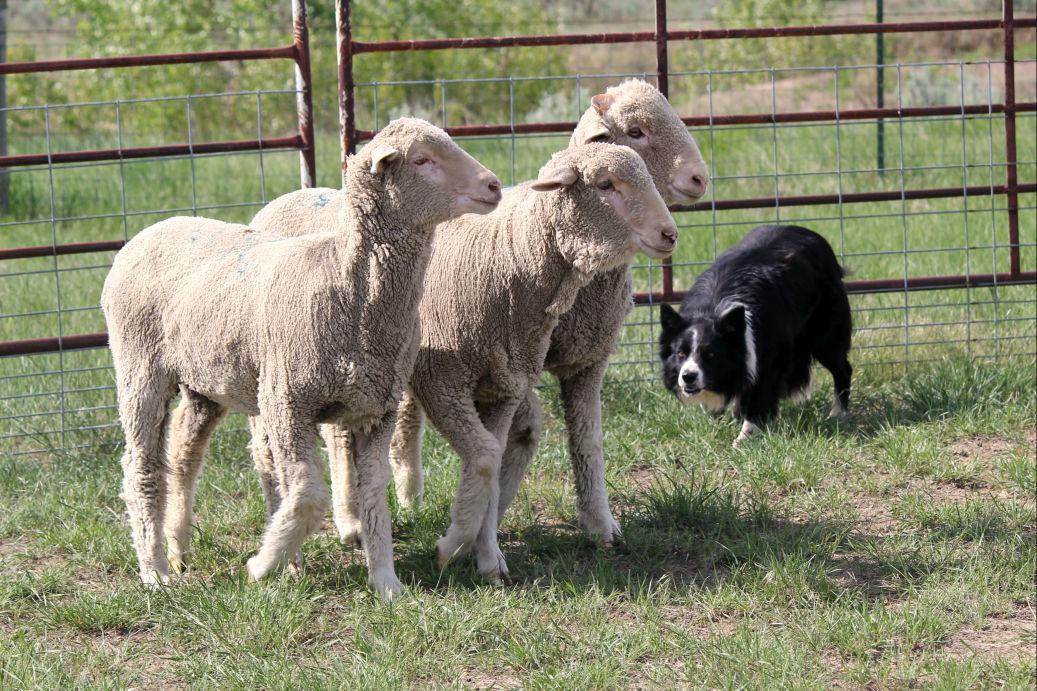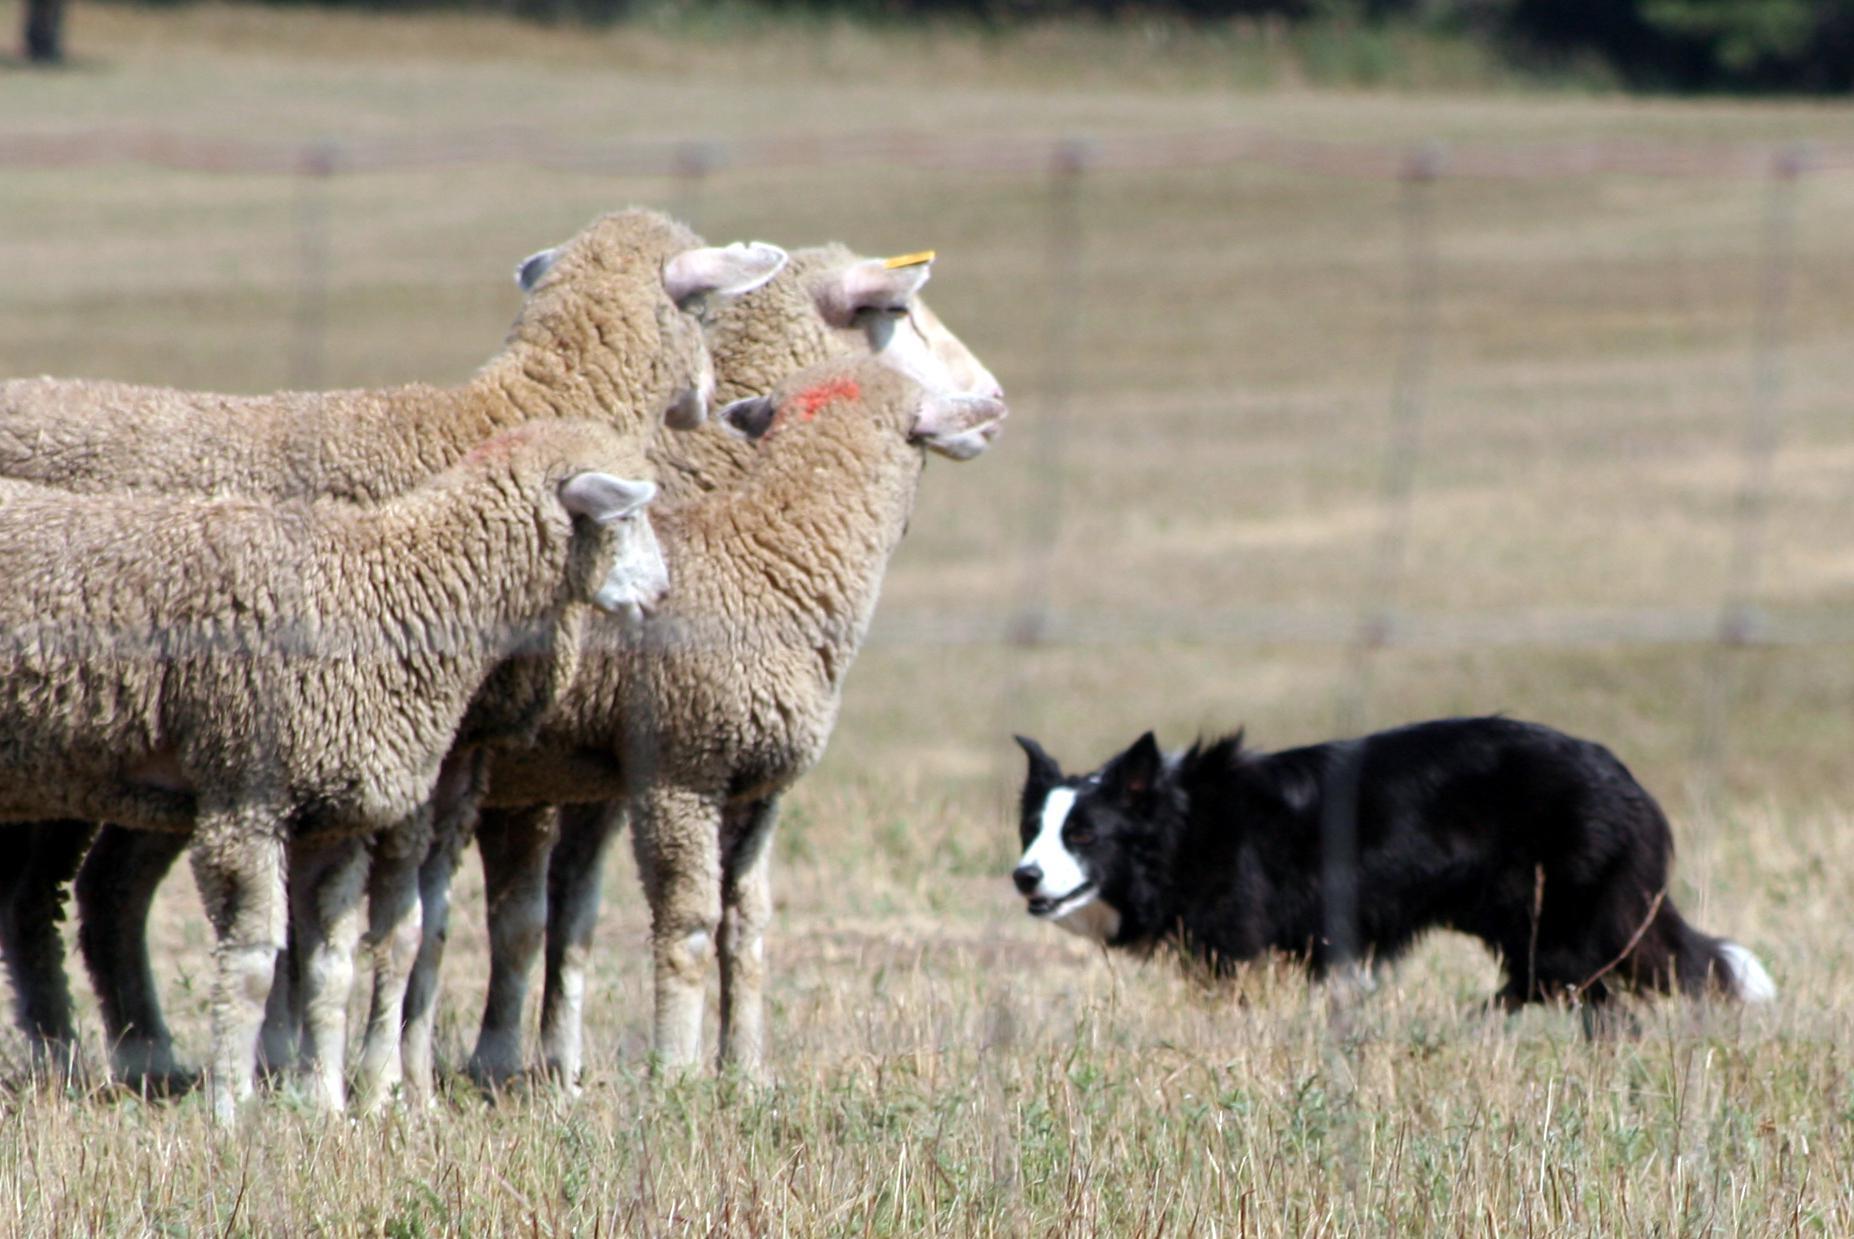The first image is the image on the left, the second image is the image on the right. Given the left and right images, does the statement "The right image contains exactly three sheep." hold true? Answer yes or no. Yes. The first image is the image on the left, the second image is the image on the right. Considering the images on both sides, is "There are less than three animals in one of the images." valid? Answer yes or no. No. 